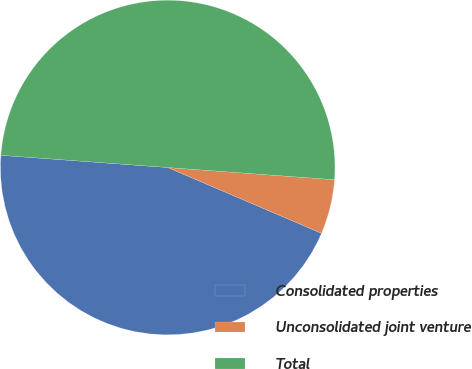Convert chart to OTSL. <chart><loc_0><loc_0><loc_500><loc_500><pie_chart><fcel>Consolidated properties<fcel>Unconsolidated joint venture<fcel>Total<nl><fcel>44.73%<fcel>5.27%<fcel>50.0%<nl></chart> 